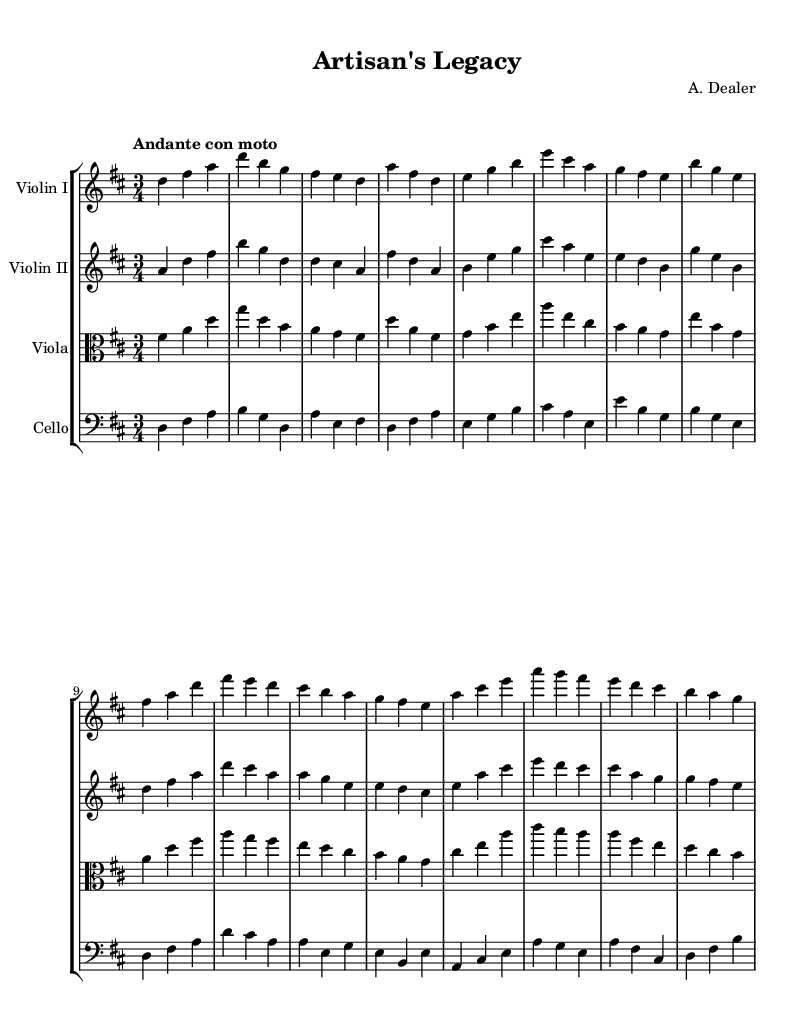What is the key signature of this music? The key signature is determined by the sharps or flats placed at the beginning of the staff. In this sheet music, there are two sharps (F# and C#), indicating the key of D major.
Answer: D major What is the time signature of this piece? The time signature is shown at the beginning of the music with a fraction. Here, it is written as 3/4, which means there are three beats in each measure, and the quarter note gets one beat.
Answer: 3/4 What is the tempo marking for this symphony? The tempo marking provides the speed at which the piece should be played. It is indicated above the staff as "Andante con moto," which describes a moderately slow pace with some movement.
Answer: Andante con moto How many instruments are featured in this score? By examining the score layout, we can count the number of staves that correspond to different instruments. There are four staves: Violin I, Violin II, Viola, and Cello.
Answer: Four Which instrument has the highest pitch range in this composition? To determine which instrument has the highest pitch range, we need to look at the clefs and the starting notes. The Violin I part uses a treble clef and typically plays higher notes compared to the other instruments, making it the highest.
Answer: Violin I What is the range of the cello notes in this score? The cello part is positioned in the bass clef, which typically plays lower notes. Looking through its melodic line, the highest note played is A in the octave above middle C, while the lowest note appears to be D from the open string. Thus, its range extends from D to A.
Answer: D to A What is the role of the viola in this orchestration? The viola usually plays inner harmonies and fills in the textures between the higher violins and the lower cello. In this score, the viola provides counter-melodies and harmonic support, enriching the overall sound of the symphony.
Answer: Harmony and counter-melody 